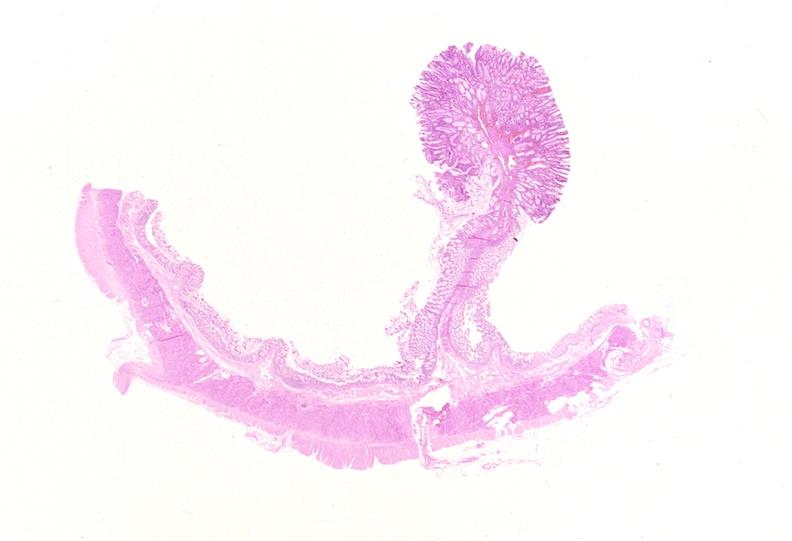what does this image show?
Answer the question using a single word or phrase. Colon 